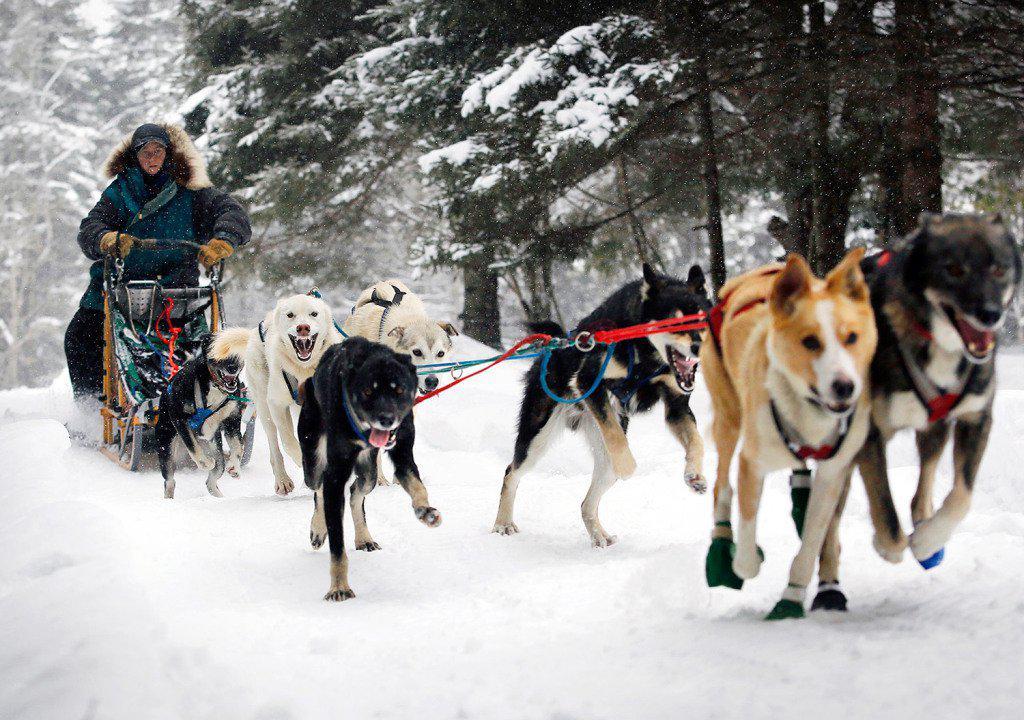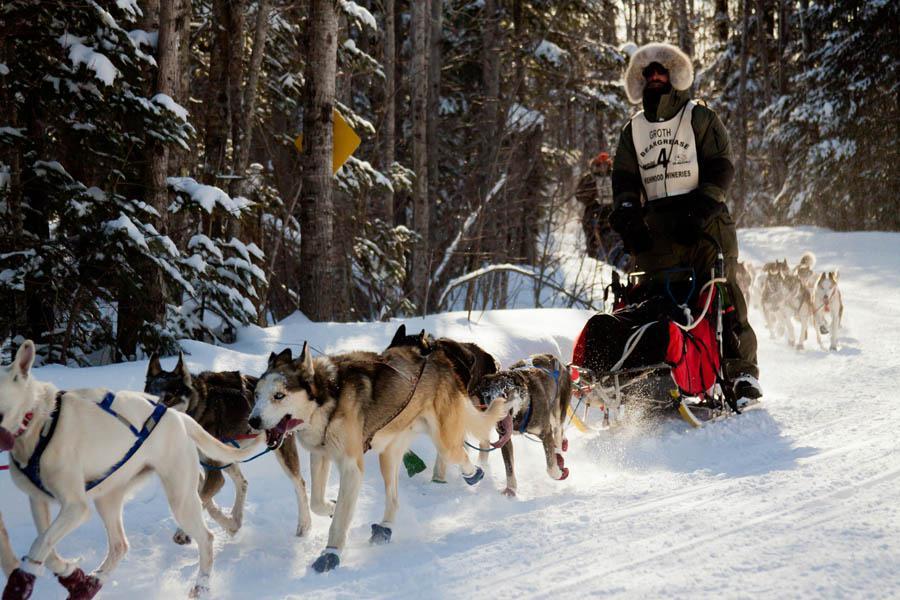The first image is the image on the left, the second image is the image on the right. Considering the images on both sides, is "A team of dogs wear the same non-black color of booties." valid? Answer yes or no. No. 